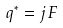<formula> <loc_0><loc_0><loc_500><loc_500>q ^ { * } = j \, F</formula> 